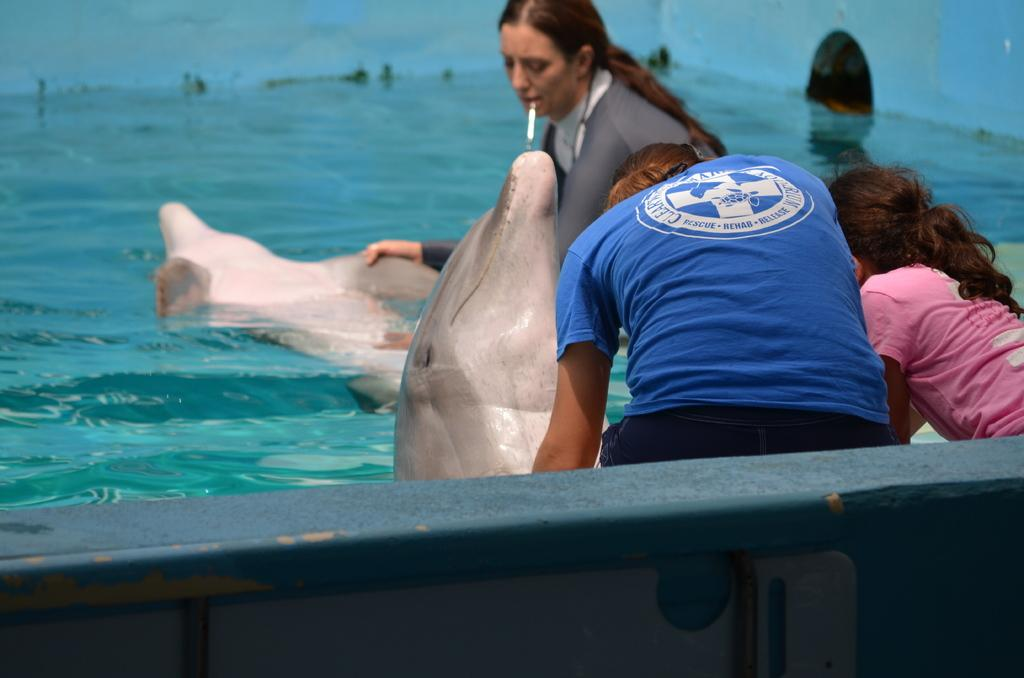What animals are in the pool in the image? There are two whales in the pool. How many people are in the pool with the whales? There are three persons in the pool. What type of locket can be seen around the neck of one of the whales in the image? There is no locket present around the neck of any whale in the image, as whales do not wear jewelry. 